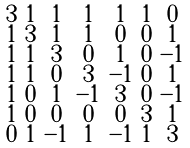<formula> <loc_0><loc_0><loc_500><loc_500>\begin{smallmatrix} 3 & 1 & 1 & 1 & 1 & 1 & 0 \\ 1 & 3 & 1 & 1 & 0 & 0 & 1 \\ 1 & 1 & 3 & 0 & 1 & 0 & - 1 \\ 1 & 1 & 0 & 3 & - 1 & 0 & 1 \\ 1 & 0 & 1 & - 1 & 3 & 0 & - 1 \\ 1 & 0 & 0 & 0 & 0 & 3 & 1 \\ 0 & 1 & - 1 & 1 & - 1 & 1 & 3 \end{smallmatrix}</formula> 